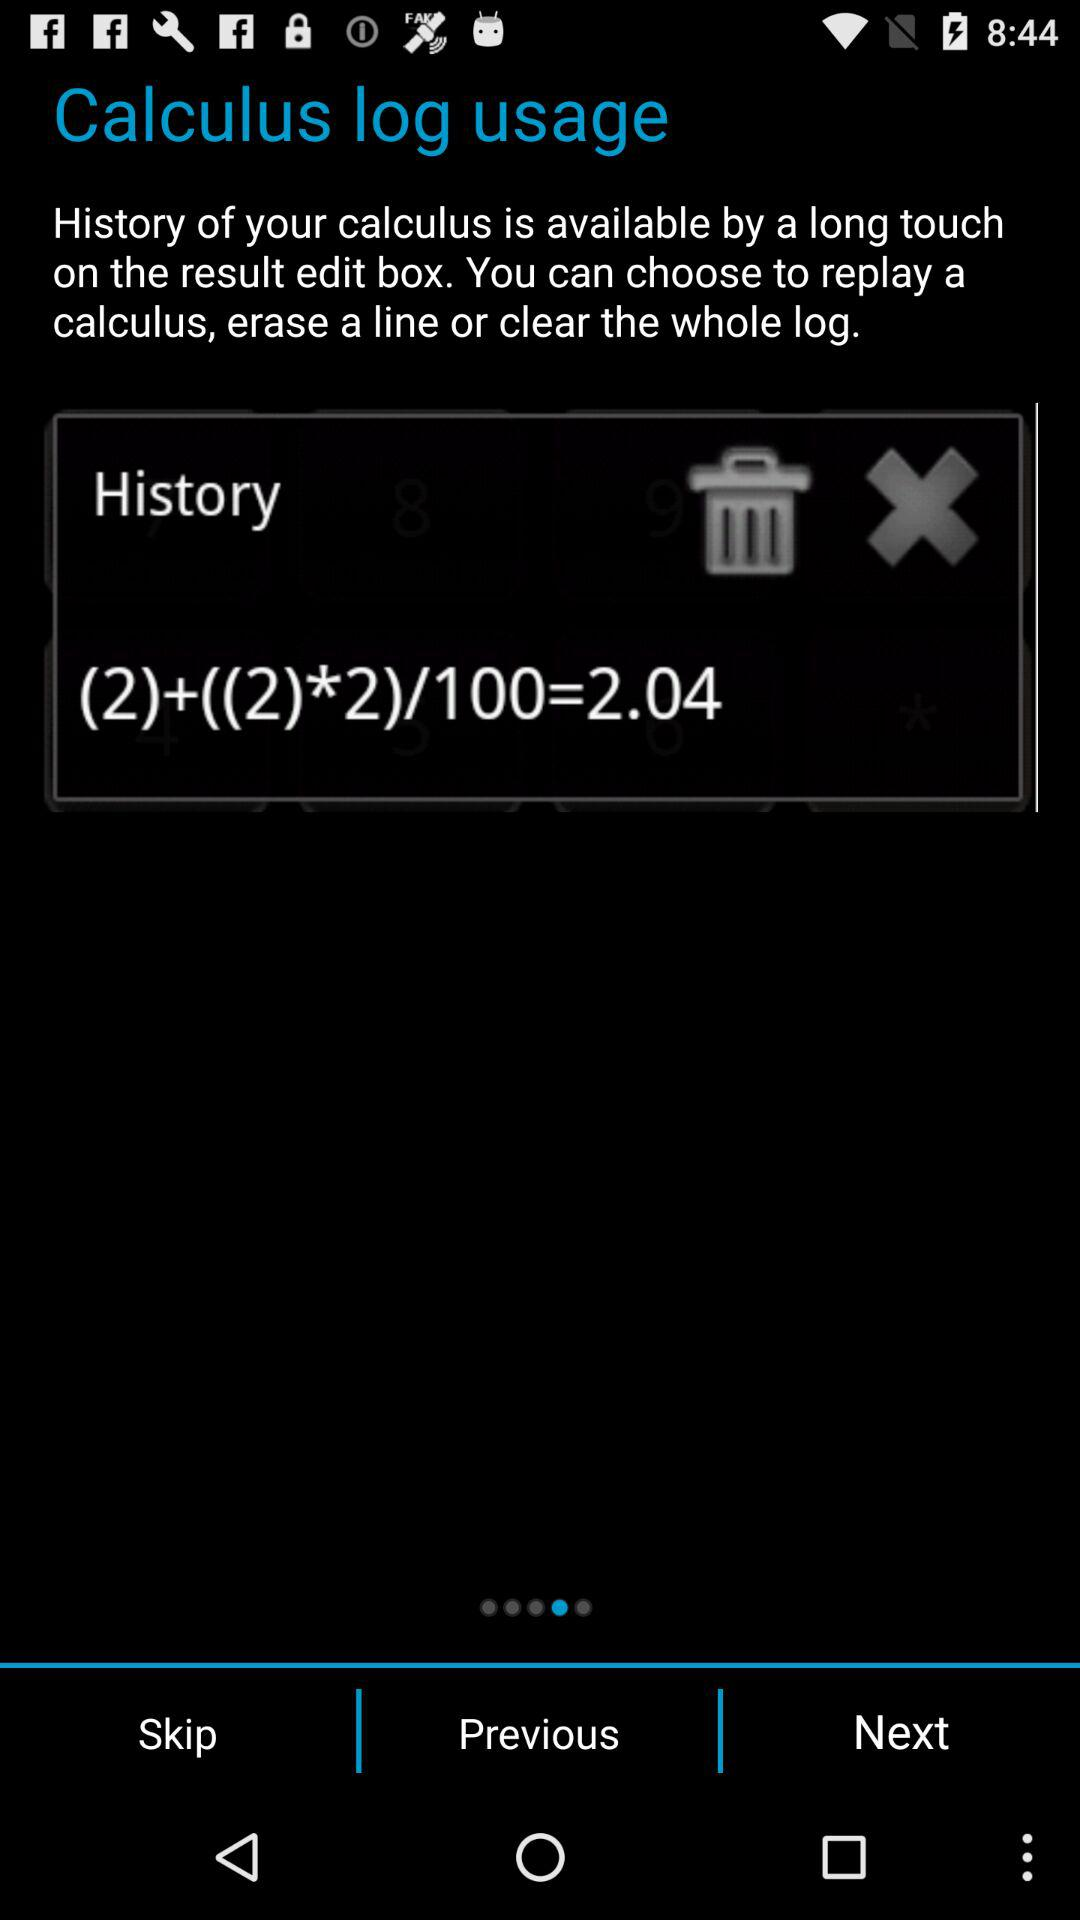What is the value of the last line in the log?
Answer the question using a single word or phrase. 2.04 